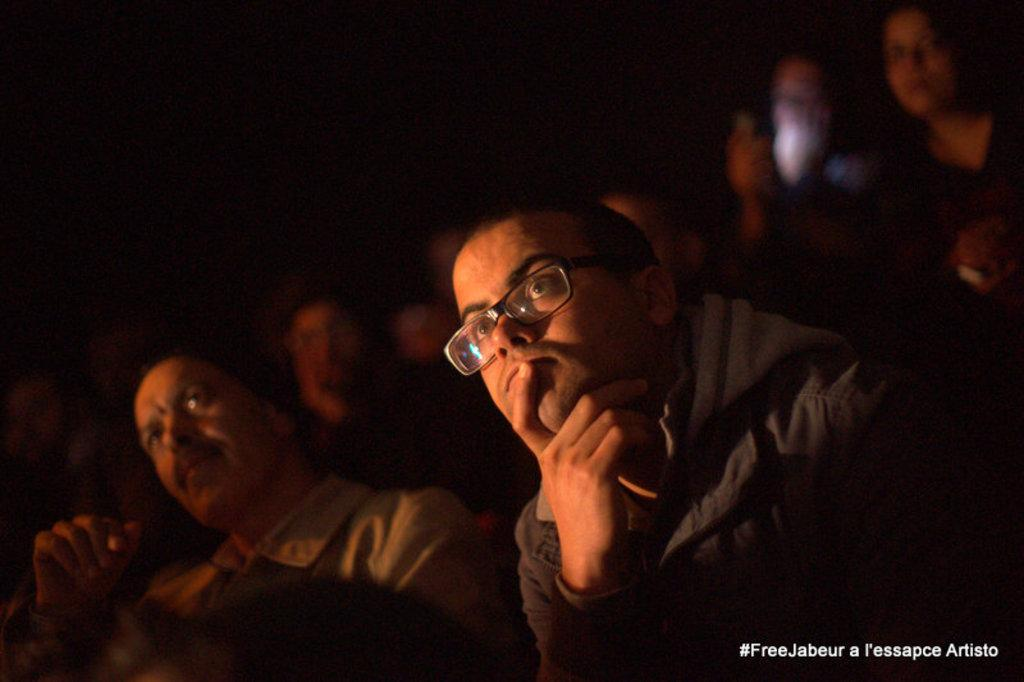What type of setting is depicted in the image? The image is an interior view of a room. Can you describe the people in the room? There is a group of people present in the room. What is written or displayed in the bottom right corner of the image? There is text in the bottom right corner of the image. What type of pleasure or profit can be gained from the discussion happening in the image? There is no discussion happening in the image, so there is no pleasure or profit to be gained from it. 